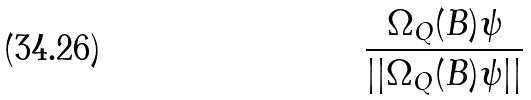Convert formula to latex. <formula><loc_0><loc_0><loc_500><loc_500>\frac { \Omega _ { Q } ( B ) \psi } { | | \Omega _ { Q } ( B ) \psi | | }</formula> 